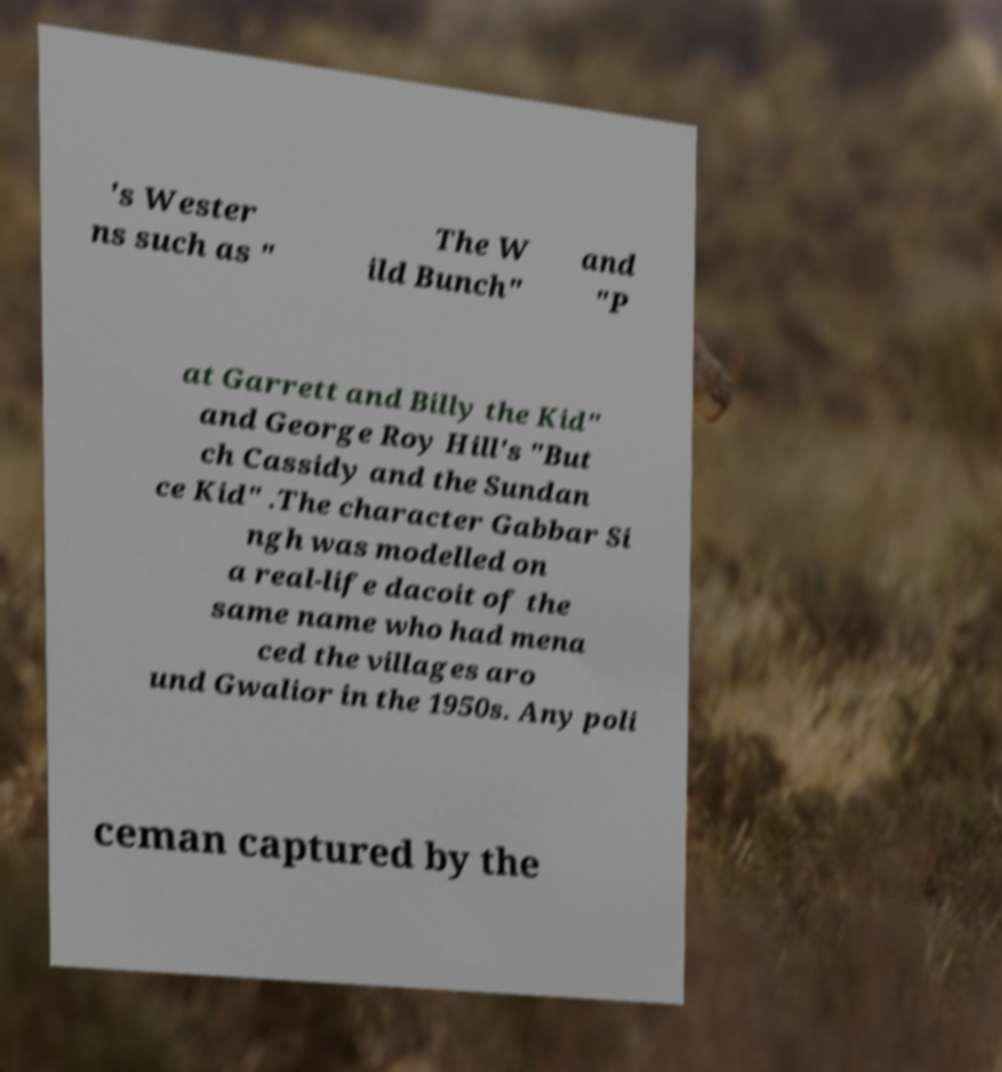I need the written content from this picture converted into text. Can you do that? 's Wester ns such as " The W ild Bunch" and "P at Garrett and Billy the Kid" and George Roy Hill's "But ch Cassidy and the Sundan ce Kid" .The character Gabbar Si ngh was modelled on a real-life dacoit of the same name who had mena ced the villages aro und Gwalior in the 1950s. Any poli ceman captured by the 